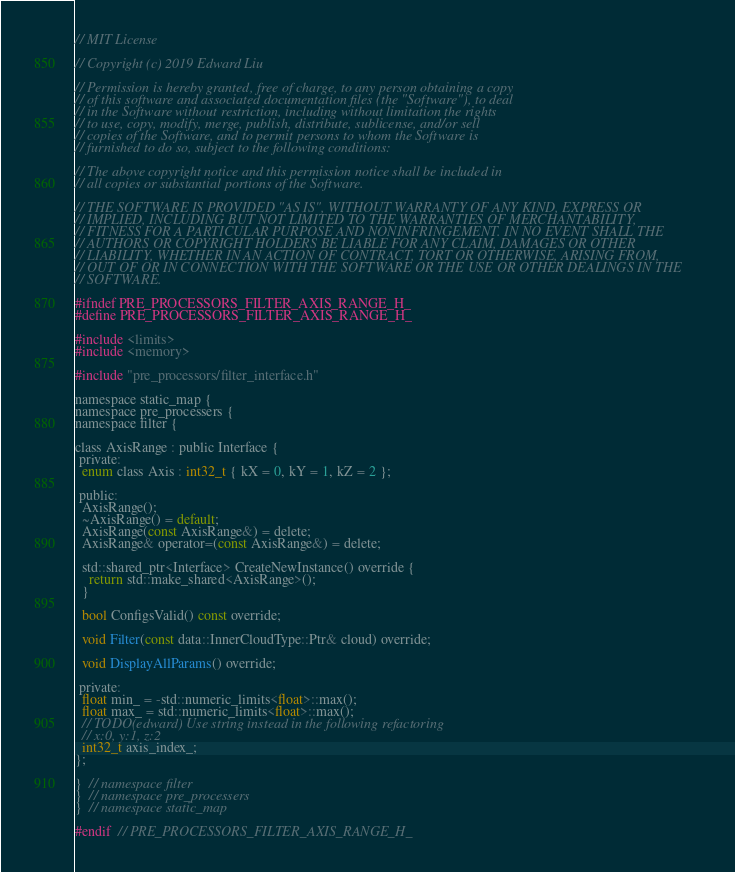Convert code to text. <code><loc_0><loc_0><loc_500><loc_500><_C_>// MIT License

// Copyright (c) 2019 Edward Liu

// Permission is hereby granted, free of charge, to any person obtaining a copy
// of this software and associated documentation files (the "Software"), to deal
// in the Software without restriction, including without limitation the rights
// to use, copy, modify, merge, publish, distribute, sublicense, and/or sell
// copies of the Software, and to permit persons to whom the Software is
// furnished to do so, subject to the following conditions:

// The above copyright notice and this permission notice shall be included in
// all copies or substantial portions of the Software.

// THE SOFTWARE IS PROVIDED "AS IS", WITHOUT WARRANTY OF ANY KIND, EXPRESS OR
// IMPLIED, INCLUDING BUT NOT LIMITED TO THE WARRANTIES OF MERCHANTABILITY,
// FITNESS FOR A PARTICULAR PURPOSE AND NONINFRINGEMENT. IN NO EVENT SHALL THE
// AUTHORS OR COPYRIGHT HOLDERS BE LIABLE FOR ANY CLAIM, DAMAGES OR OTHER
// LIABILITY, WHETHER IN AN ACTION OF CONTRACT, TORT OR OTHERWISE, ARISING FROM,
// OUT OF OR IN CONNECTION WITH THE SOFTWARE OR THE USE OR OTHER DEALINGS IN THE
// SOFTWARE.

#ifndef PRE_PROCESSORS_FILTER_AXIS_RANGE_H_
#define PRE_PROCESSORS_FILTER_AXIS_RANGE_H_

#include <limits>
#include <memory>

#include "pre_processors/filter_interface.h"

namespace static_map {
namespace pre_processers {
namespace filter {

class AxisRange : public Interface {
 private:
  enum class Axis : int32_t { kX = 0, kY = 1, kZ = 2 };

 public:
  AxisRange();
  ~AxisRange() = default;
  AxisRange(const AxisRange&) = delete;
  AxisRange& operator=(const AxisRange&) = delete;

  std::shared_ptr<Interface> CreateNewInstance() override {
    return std::make_shared<AxisRange>();
  }

  bool ConfigsValid() const override;

  void Filter(const data::InnerCloudType::Ptr& cloud) override;

  void DisplayAllParams() override;

 private:
  float min_ = -std::numeric_limits<float>::max();
  float max_ = std::numeric_limits<float>::max();
  // TODO(edward) Use string instead in the following refactoring
  // x:0, y:1, z:2
  int32_t axis_index_;
};

}  // namespace filter
}  // namespace pre_processers
}  // namespace static_map

#endif  // PRE_PROCESSORS_FILTER_AXIS_RANGE_H_
</code> 